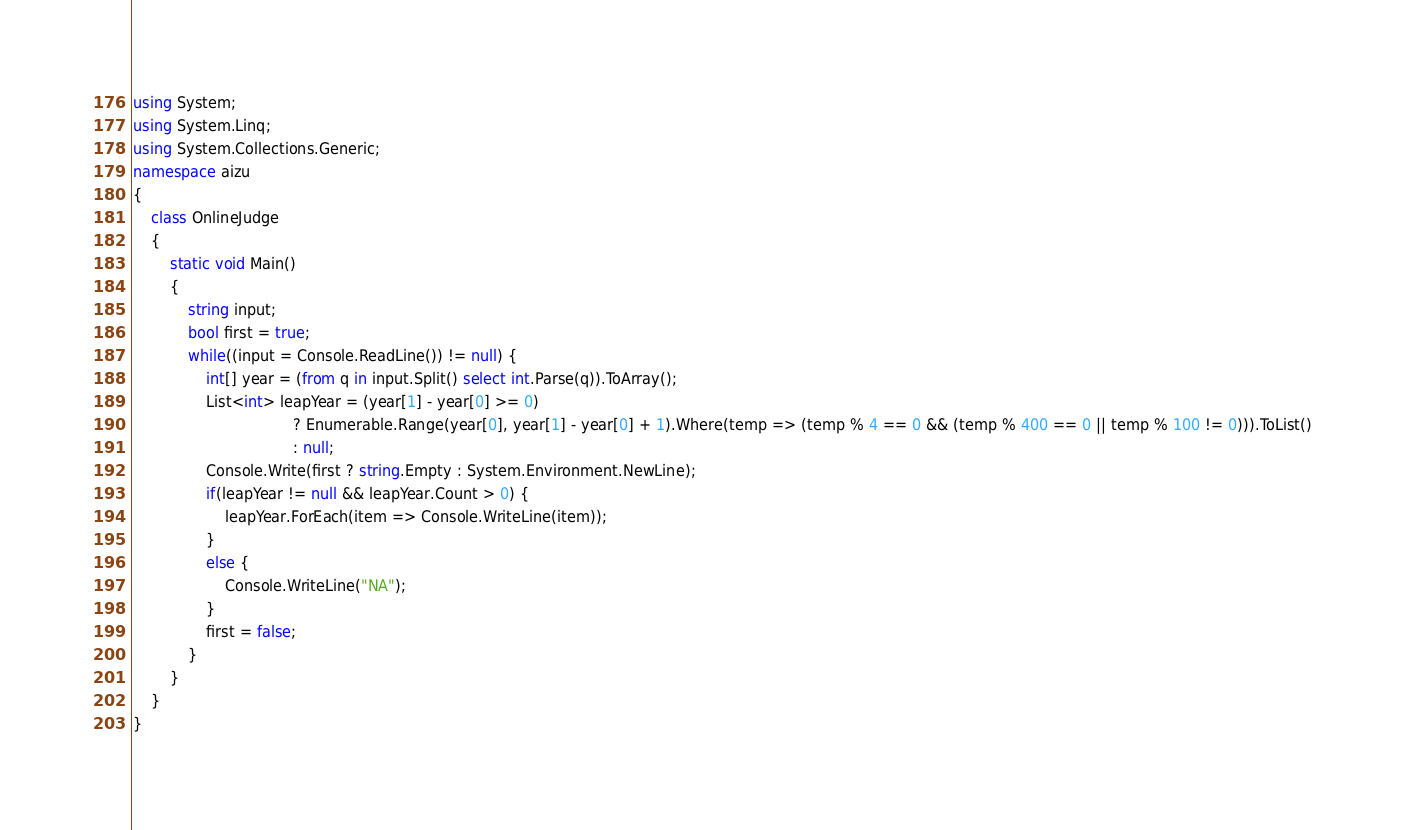<code> <loc_0><loc_0><loc_500><loc_500><_C#_>using System;
using System.Linq;
using System.Collections.Generic;
namespace aizu
{
    class OnlineJudge
    {
        static void Main()
        {
            string input;
            bool first = true;
            while((input = Console.ReadLine()) != null) {
                int[] year = (from q in input.Split() select int.Parse(q)).ToArray();
                List<int> leapYear = (year[1] - year[0] >= 0)
                                   ? Enumerable.Range(year[0], year[1] - year[0] + 1).Where(temp => (temp % 4 == 0 && (temp % 400 == 0 || temp % 100 != 0))).ToList()
                                   : null;
                Console.Write(first ? string.Empty : System.Environment.NewLine);
                if(leapYear != null && leapYear.Count > 0) {
                    leapYear.ForEach(item => Console.WriteLine(item));
                }
                else {
                    Console.WriteLine("NA");
                }
                first = false;
            }
        }
    }
}</code> 